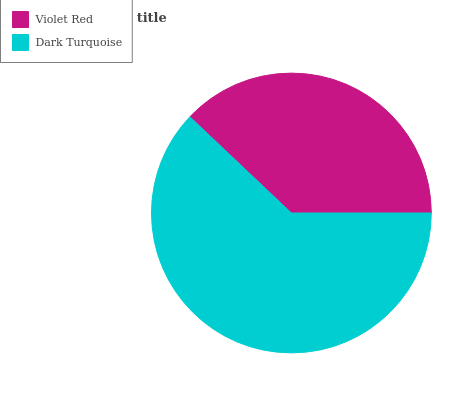Is Violet Red the minimum?
Answer yes or no. Yes. Is Dark Turquoise the maximum?
Answer yes or no. Yes. Is Dark Turquoise the minimum?
Answer yes or no. No. Is Dark Turquoise greater than Violet Red?
Answer yes or no. Yes. Is Violet Red less than Dark Turquoise?
Answer yes or no. Yes. Is Violet Red greater than Dark Turquoise?
Answer yes or no. No. Is Dark Turquoise less than Violet Red?
Answer yes or no. No. Is Dark Turquoise the high median?
Answer yes or no. Yes. Is Violet Red the low median?
Answer yes or no. Yes. Is Violet Red the high median?
Answer yes or no. No. Is Dark Turquoise the low median?
Answer yes or no. No. 